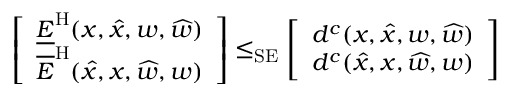Convert formula to latex. <formula><loc_0><loc_0><loc_500><loc_500>\left [ \begin{array} { l } { \underline { E } ^ { H } ( x , \widehat { x } , w , \widehat { w } ) } \\ { \overline { E } ^ { H } ( \widehat { x } , x , \widehat { w } , w ) } \end{array} \right ] \leq _ { S E } \left [ \begin{array} { l } { d ^ { c } ( x , \widehat { x } , w , \widehat { w } ) } \\ { d ^ { c } ( \widehat { x } , x , \widehat { w } , w ) } \end{array} \right ]</formula> 